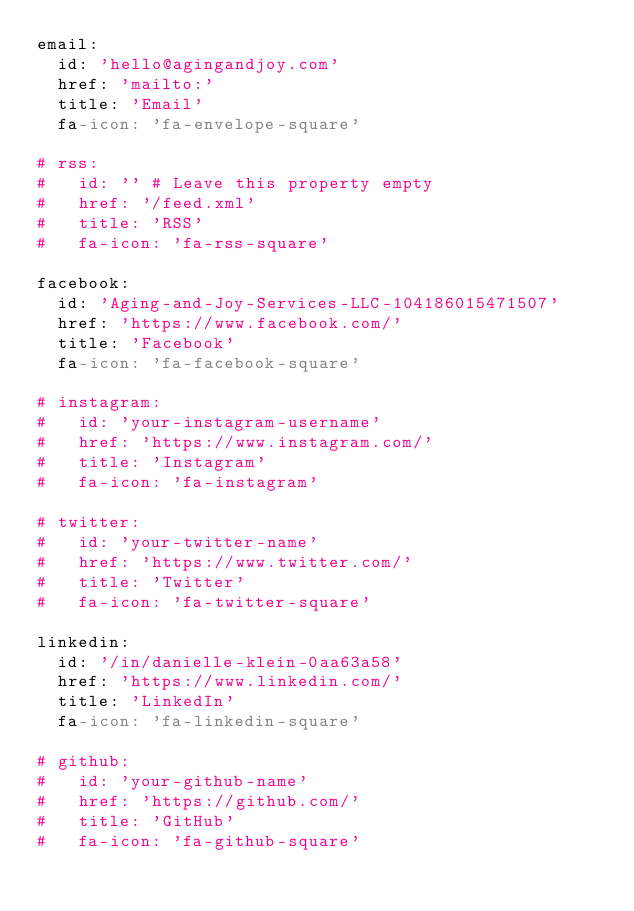<code> <loc_0><loc_0><loc_500><loc_500><_YAML_>email:
  id: 'hello@agingandjoy.com'
  href: 'mailto:'
  title: 'Email'
  fa-icon: 'fa-envelope-square'

# rss:
#   id: '' # Leave this property empty
#   href: '/feed.xml'
#   title: 'RSS'
#   fa-icon: 'fa-rss-square'

facebook:
  id: 'Aging-and-Joy-Services-LLC-104186015471507'
  href: 'https://www.facebook.com/'
  title: 'Facebook'
  fa-icon: 'fa-facebook-square'

# instagram:
#   id: 'your-instagram-username'
#   href: 'https://www.instagram.com/'
#   title: 'Instagram'
#   fa-icon: 'fa-instagram'

# twitter:
#   id: 'your-twitter-name'
#   href: 'https://www.twitter.com/'
#   title: 'Twitter'
#   fa-icon: 'fa-twitter-square'

linkedin:
  id: '/in/danielle-klein-0aa63a58'
  href: 'https://www.linkedin.com/'
  title: 'LinkedIn'
  fa-icon: 'fa-linkedin-square'

# github:
#   id: 'your-github-name'
#   href: 'https://github.com/'
#   title: 'GitHub'
#   fa-icon: 'fa-github-square'</code> 